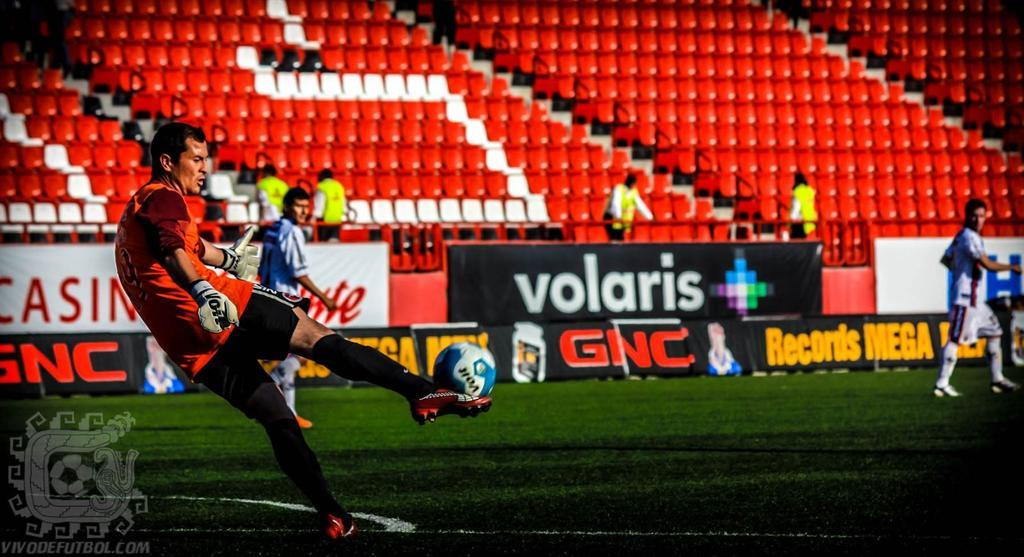<image>
Offer a succinct explanation of the picture presented. Sponsor's names such as "Volaris" and "GNC" are presented in front of the white and red seats. 